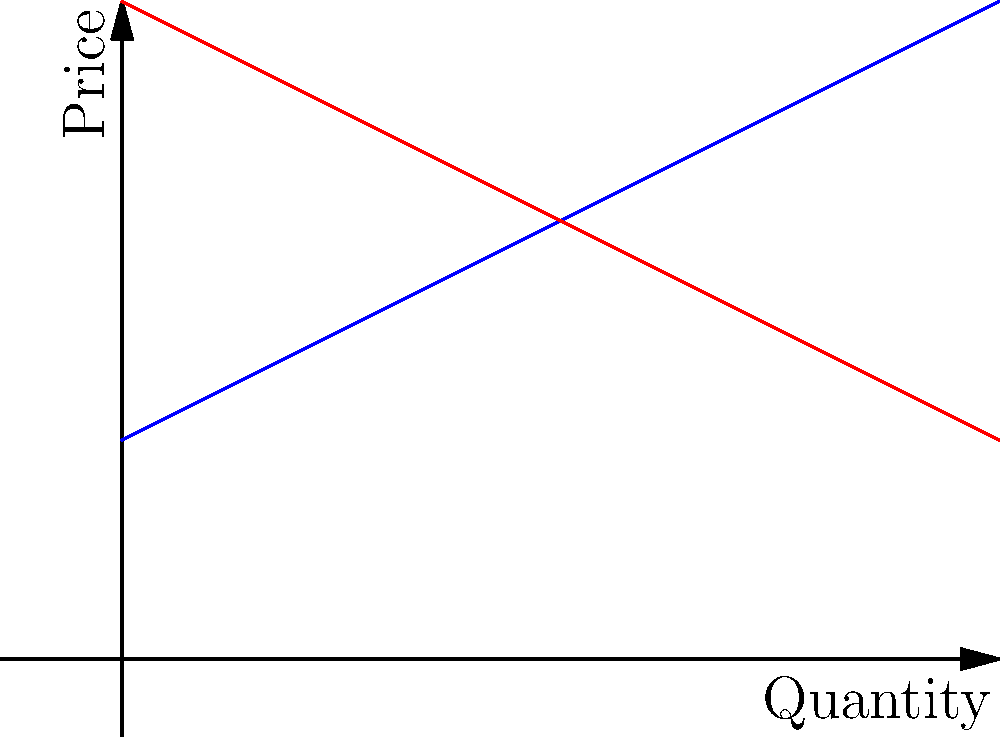In the given supply and demand graph, what economic concept is represented by the intersection point of the two curves? How would you calculate the equilibrium price and quantity? To answer this question, let's break it down step-by-step:

1. The intersection point of supply and demand curves represents the equilibrium in a market.

2. At this point, the quantity supplied equals the quantity demanded, and the market clears.

3. To calculate the equilibrium price and quantity:
   a) Observe that the supply curve (blue) has the equation: $P = 5 + 0.5Q$
   b) The demand curve (red) has the equation: $P = 15 - 0.5Q$

4. At equilibrium, these equations are equal:
   $5 + 0.5Q = 15 - 0.5Q$

5. Solve for Q:
   $5 + 0.5Q = 15 - 0.5Q$
   $1Q = 10$
   $Q = 10$

6. Substitute Q=10 into either equation to find P:
   $P = 5 + 0.5(10) = 10$

Therefore, the equilibrium price is $10 and the equilibrium quantity is 10 units.

This intersection point represents market equilibrium, where supply and demand are balanced, and there is no pressure for price or quantity to change.
Answer: Market equilibrium; P=$10, Q=10 